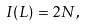Convert formula to latex. <formula><loc_0><loc_0><loc_500><loc_500>I ( L ) = 2 N ,</formula> 